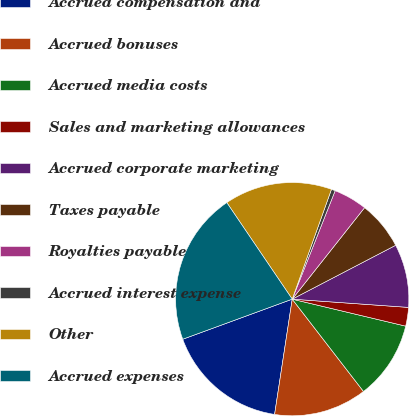Convert chart to OTSL. <chart><loc_0><loc_0><loc_500><loc_500><pie_chart><fcel>Accrued compensation and<fcel>Accrued bonuses<fcel>Accrued media costs<fcel>Sales and marketing allowances<fcel>Accrued corporate marketing<fcel>Taxes payable<fcel>Royalties payable<fcel>Accrued interest expense<fcel>Other<fcel>Accrued expenses<nl><fcel>17.0%<fcel>12.88%<fcel>10.82%<fcel>2.59%<fcel>8.77%<fcel>6.71%<fcel>4.65%<fcel>0.54%<fcel>14.94%<fcel>21.11%<nl></chart> 